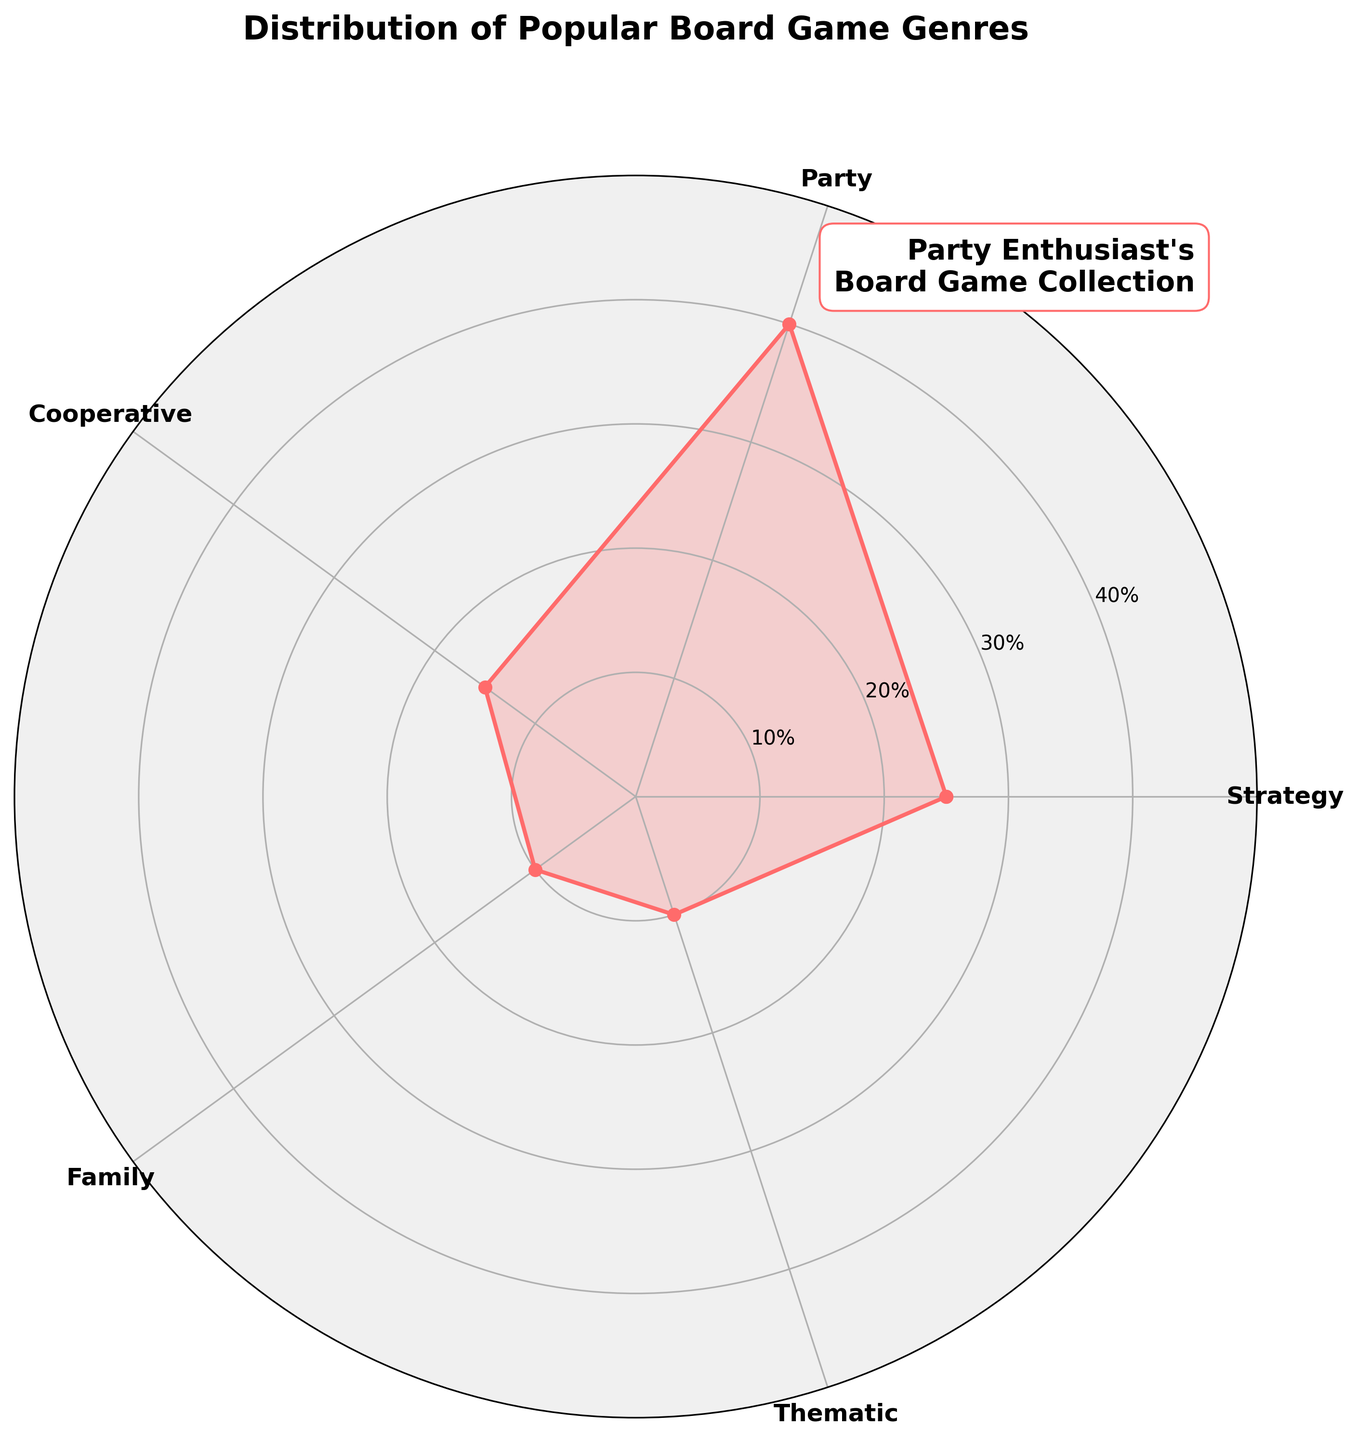What is the title of the chart? The title is usually found at the top of the chart. In this chart, the title is prominently displayed.
Answer: Distribution of Popular Board Game Genres Which genre has the highest percentage? To find this, look at all the plotted values and identify the genre with the longest line from the center.
Answer: Party What percentage of guests prefer Strategy games? This can be seen by locating the point on the chart corresponding to "Strategy" and reading its value along the radial axis.
Answer: 25% What is the total percentage of guests that prefer Cooperative and Family games combined? Add the percentages for Cooperative and Family genres: 15% + 10%.
Answer: 25% How does the percentage of guests who prefer Thematic games compare to those who prefer Family games? Compare the percentage values of Thematic (10%) and Family (10%) on the chart.
Answer: Equal Which genre is preferred by the least percentage of guests? Identify the genre with the shortest line from the center of the chart. Both Family and Thematic have the same shortest length.
Answer: Family and Thematic What is the combined percentage of guests who prefer Strategy, Party, and Cooperative games? Sum the percentages of Strategy (25%), Party (40%), and Cooperative (15%): 25 + 40 + 15 = 80%.
Answer: 80% How many unique genres are represented on the chart? Count the distinct genre labels on the chart.
Answer: 5 What's the difference in percentage between Party and Cooperative genres? Subtract the percentage of Cooperative from the percentage of Party: 40% - 15%.
Answer: 25% Which genres have the same percentage of preference among the guests? Look for genres with the same length of lines from the center, indicated by the radial axis values.
Answer: Family and Thematic 